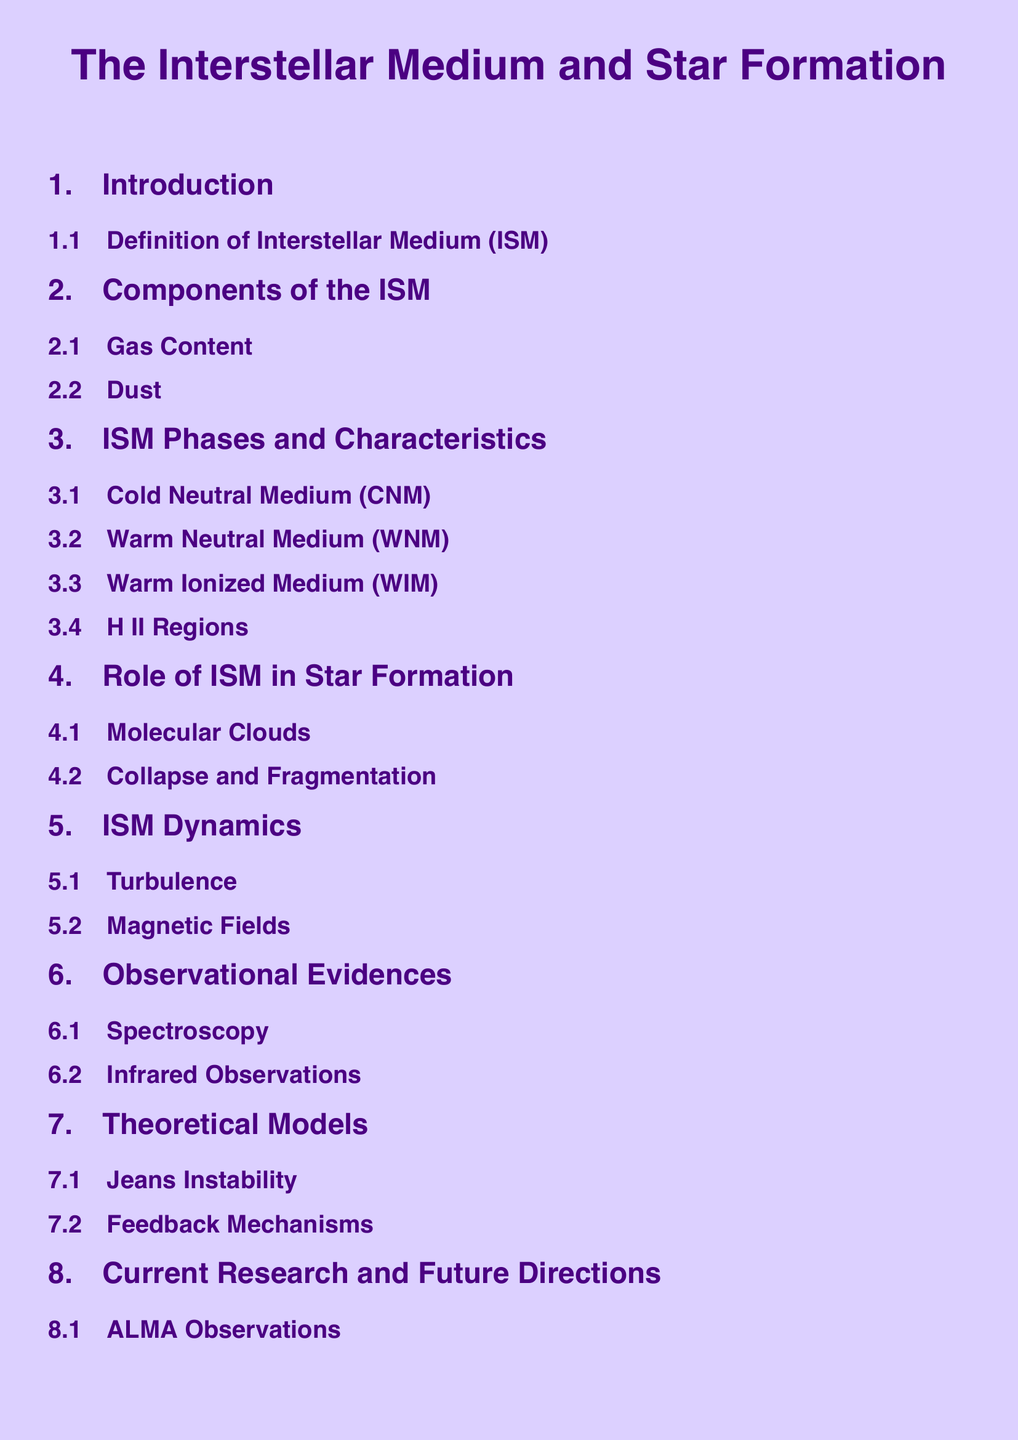what is the first section of the document? The first section provides an overview of the ISM, including a definition.
Answer: Introduction what are the primary components of the ISM? The primary components of the ISM discussed are gas and dust.
Answer: Gas Content, Dust how many phases of ISM are listed in the document? The document lists four phases of ISM.
Answer: Four what is a key aspect of the role of ISM in star formation? A key aspect mentioned is the presence of molecular clouds.
Answer: Molecular Clouds which observational method is mentioned for studying the ISM? The document mentions spectroscopy as one of the methods for studying the ISM.
Answer: Spectroscopy what theoretical concept related to star formation is described in the document? The document describes the concept of Jeans Instability.
Answer: Jeans Instability name one current research direction in ISM studies. The document indicates that ALMA observations are a current area of research.
Answer: ALMA Observations what is the focus of the conclusion section? The conclusion section summarizes the key points of the document.
Answer: Summary 